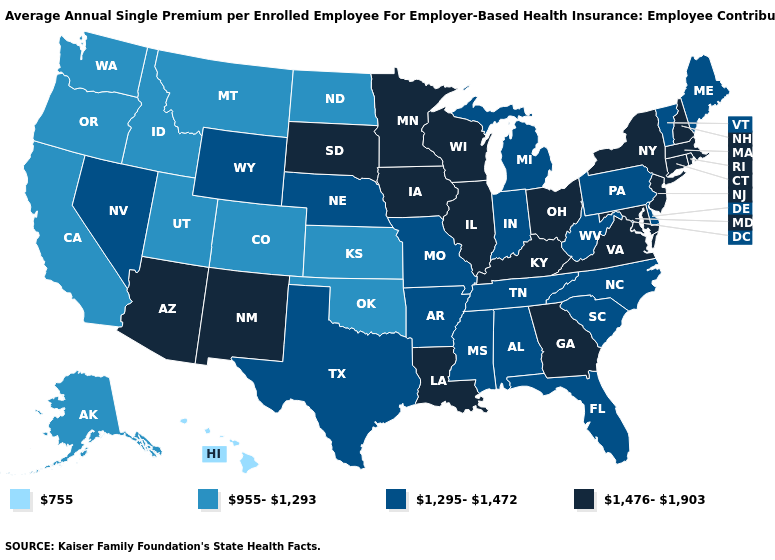Name the states that have a value in the range 1,476-1,903?
Be succinct. Arizona, Connecticut, Georgia, Illinois, Iowa, Kentucky, Louisiana, Maryland, Massachusetts, Minnesota, New Hampshire, New Jersey, New Mexico, New York, Ohio, Rhode Island, South Dakota, Virginia, Wisconsin. Does the map have missing data?
Quick response, please. No. Name the states that have a value in the range 1,295-1,472?
Give a very brief answer. Alabama, Arkansas, Delaware, Florida, Indiana, Maine, Michigan, Mississippi, Missouri, Nebraska, Nevada, North Carolina, Pennsylvania, South Carolina, Tennessee, Texas, Vermont, West Virginia, Wyoming. What is the highest value in states that border Alabama?
Answer briefly. 1,476-1,903. Does Oregon have the lowest value in the West?
Keep it brief. No. Does Rhode Island have the lowest value in the USA?
Answer briefly. No. Name the states that have a value in the range 955-1,293?
Short answer required. Alaska, California, Colorado, Idaho, Kansas, Montana, North Dakota, Oklahoma, Oregon, Utah, Washington. Does South Carolina have the highest value in the USA?
Short answer required. No. What is the highest value in states that border Michigan?
Answer briefly. 1,476-1,903. What is the value of West Virginia?
Quick response, please. 1,295-1,472. Which states hav the highest value in the West?
Answer briefly. Arizona, New Mexico. What is the value of Idaho?
Keep it brief. 955-1,293. Name the states that have a value in the range 1,295-1,472?
Keep it brief. Alabama, Arkansas, Delaware, Florida, Indiana, Maine, Michigan, Mississippi, Missouri, Nebraska, Nevada, North Carolina, Pennsylvania, South Carolina, Tennessee, Texas, Vermont, West Virginia, Wyoming. Which states have the lowest value in the West?
Write a very short answer. Hawaii. 